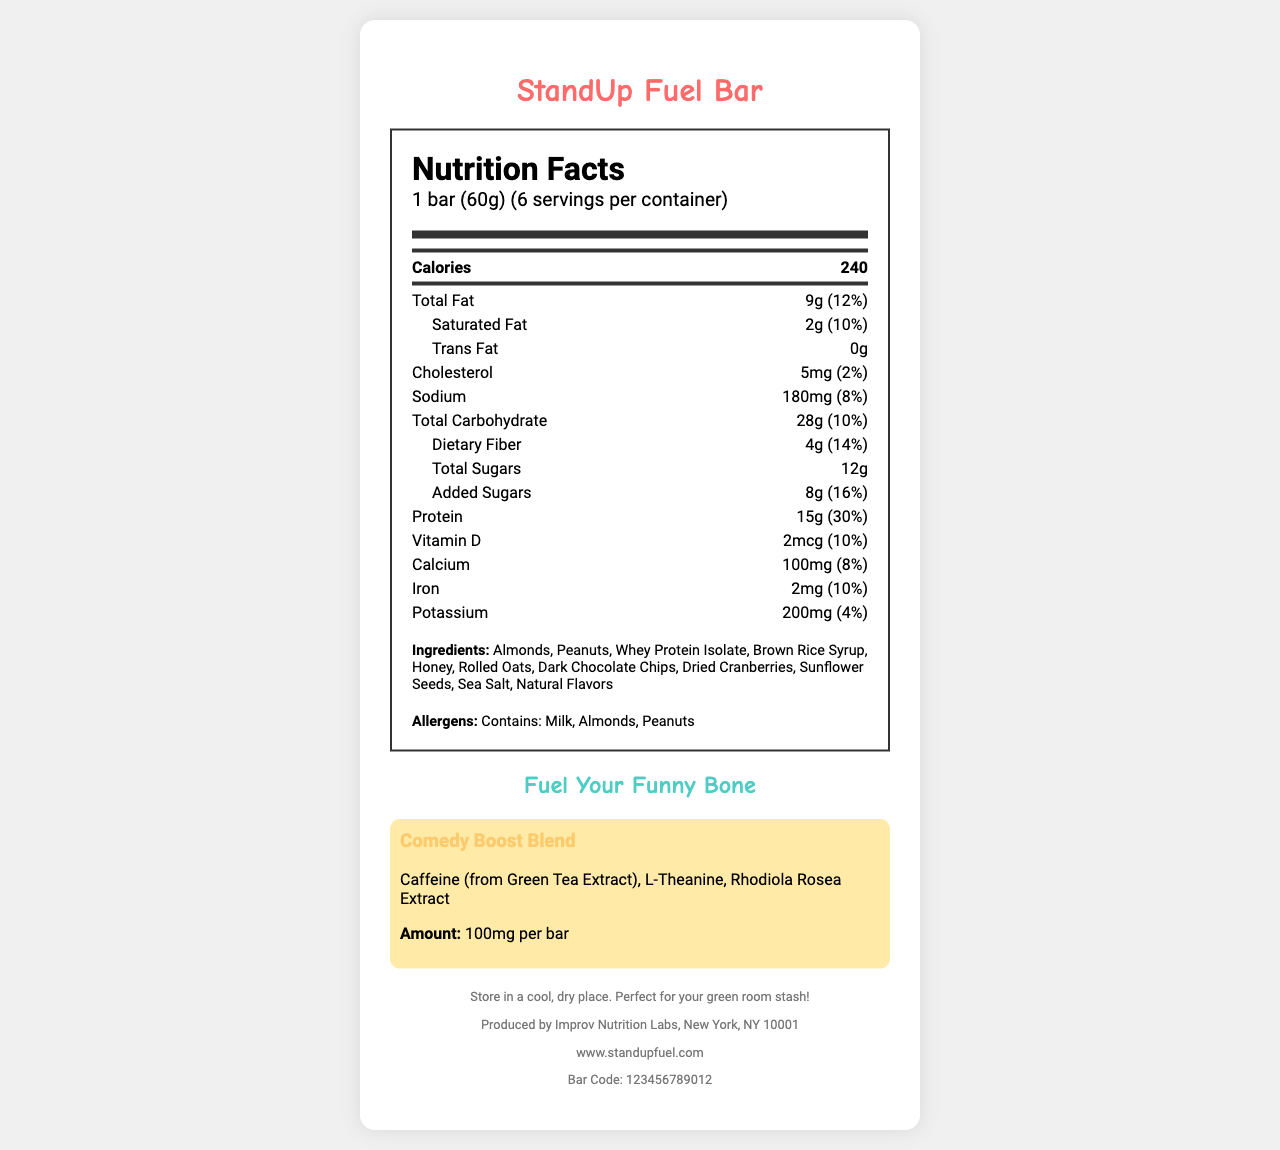what is the serving size of the StandUp Fuel Bar? The serving size is listed at the beginning of the Nutrition Facts section.
Answer: 1 bar (60g) how many servings are in one container? Under the nutrition header, it states that there are 6 servings per container.
Answer: 6 how many grams of protein does one bar contain? The protein content is specified as 15g with a daily value of 30%.
Answer: 15g what is the daily value percentage for total fat? The daily value percentage for total fat is mentioned right next to the amount in grams.
Answer: 12% what allergens are present in the StandUp Fuel Bar? The allergens are listed together under a specific section labeled "Allergens."
Answer: Milk, Almonds, Peanuts how many calories are in one serving of the StandUp Fuel Bar? The calorie count is featured prominently in the main nutrition facts section.
Answer: 240 does the StandUp Fuel Bar contain any trans fat? The document states that the bar has 0g of trans fat.
Answer: No what is the intended benefit of the "Comedy Boost Blend"? The "Comedy Boost Blend" includes ingredients like Caffeine, L-Theanine, and Rhodiola Rosea Extract, commonly used for such purposes.
Answer: Enhanced focus and energy which statement is accurate about the sugars in the StandUp Fuel Bar? A. The bar contains only natural sugars. B. The bar contains both natural and added sugars. C. The bar contains only added sugars. The total sugars are 12g, and 8g of those are added sugars.
Answer: B what percentage of your daily calcium needs does one bar fulfill? The daily value percentage for calcium is clearly specified as 8%.
Answer: 8% how much dietary fiber is in one serving of the StandUp Fuel Bar? The dietary fiber content is listed as 4g with a daily value of 14%.
Answer: 4g what is the tagline of the StandUp Fuel Bar? The tagline is highlighted towards the end of the document.
Answer: Fuel Your Funny Bone which ingredient is NOT part of the Comedy Boost Blend? A. Caffeine B. L-Theanine C. Sea Salt D. Rhodiola Rosea Extract Sea Salt is not mentioned in the Comedy Boost Blend section.
Answer: C is the StandUp Fuel Bar suitable for someone with a peanut allergy? The document clearly states it contains almonds and peanuts.
Answer: No describe the main nutritional highlights of the StandUp Fuel Bar. It summarizes the caloric content, macronutrients, and unique ingredients aimed at enhancing focus and energy.
Answer: The StandUp Fuel Bar contains 240 calories per serving, has 9g of total fat, 15g of protein, and includes a special Comedy Boost Blend of caffeine, L-Theanine, and Rhodiola Rosea Extract. what is the exact amount of Vitamin D in one serving? The amount of Vitamin D per serving is listed under the vitamin and mineral details.
Answer: 2mcg how is the document organized? This explanation covers the structure of the document and the sections in order.
Answer: The document begins with the product name, serving size, and number of servings per container. Then it details the nutrition facts, including calories and various nutrients. Allergens and ingredient information follow, ending with additional product features like the tagline and unique blends, storage instructions, company info, and a barcode. 